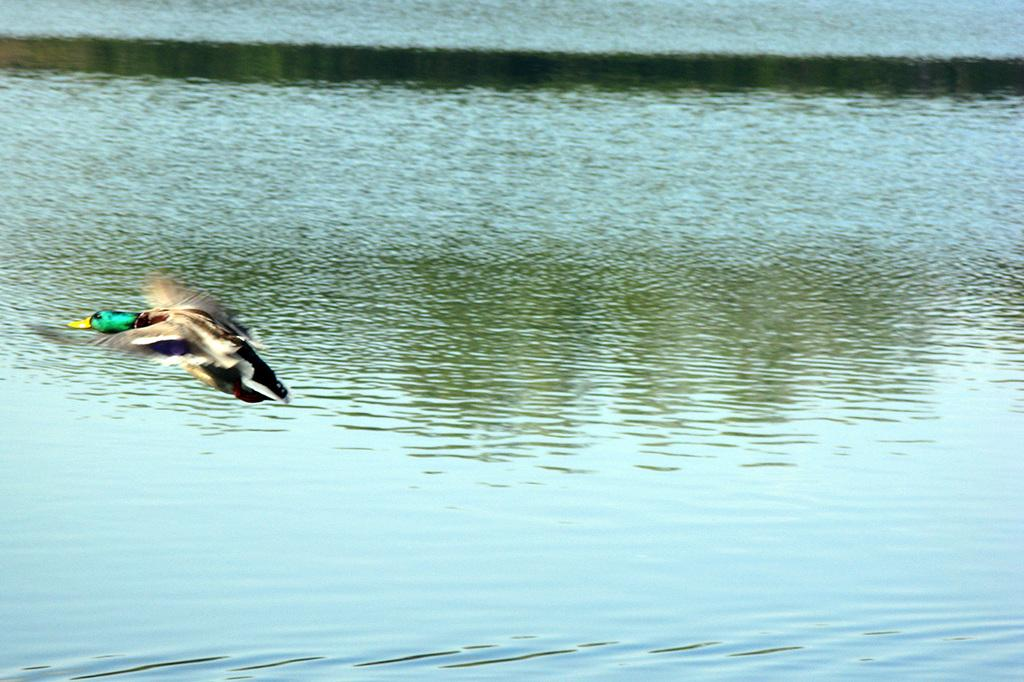What type of animal can be seen in the image? There is a bird in the image. What is visible at the bottom of the image? There is water visible at the bottom of the image. How does the grandfather express his anger in the image? There is no grandfather or expression of anger present in the image; it features a bird and water. What type of bird is the robin in the image? There is no robin or reference to a robin in the image; it only features a bird. 